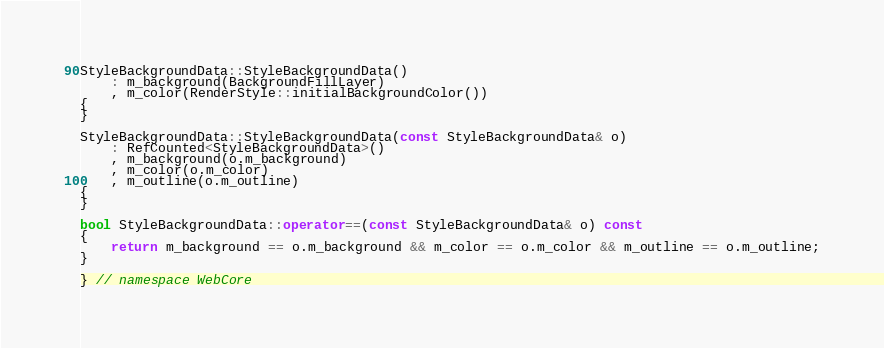<code> <loc_0><loc_0><loc_500><loc_500><_C++_>
StyleBackgroundData::StyleBackgroundData()
    : m_background(BackgroundFillLayer)
    , m_color(RenderStyle::initialBackgroundColor())
{
}

StyleBackgroundData::StyleBackgroundData(const StyleBackgroundData& o)
    : RefCounted<StyleBackgroundData>()
    , m_background(o.m_background)
    , m_color(o.m_color)
    , m_outline(o.m_outline)
{
}

bool StyleBackgroundData::operator==(const StyleBackgroundData& o) const
{
    return m_background == o.m_background && m_color == o.m_color && m_outline == o.m_outline;
}

} // namespace WebCore
</code> 